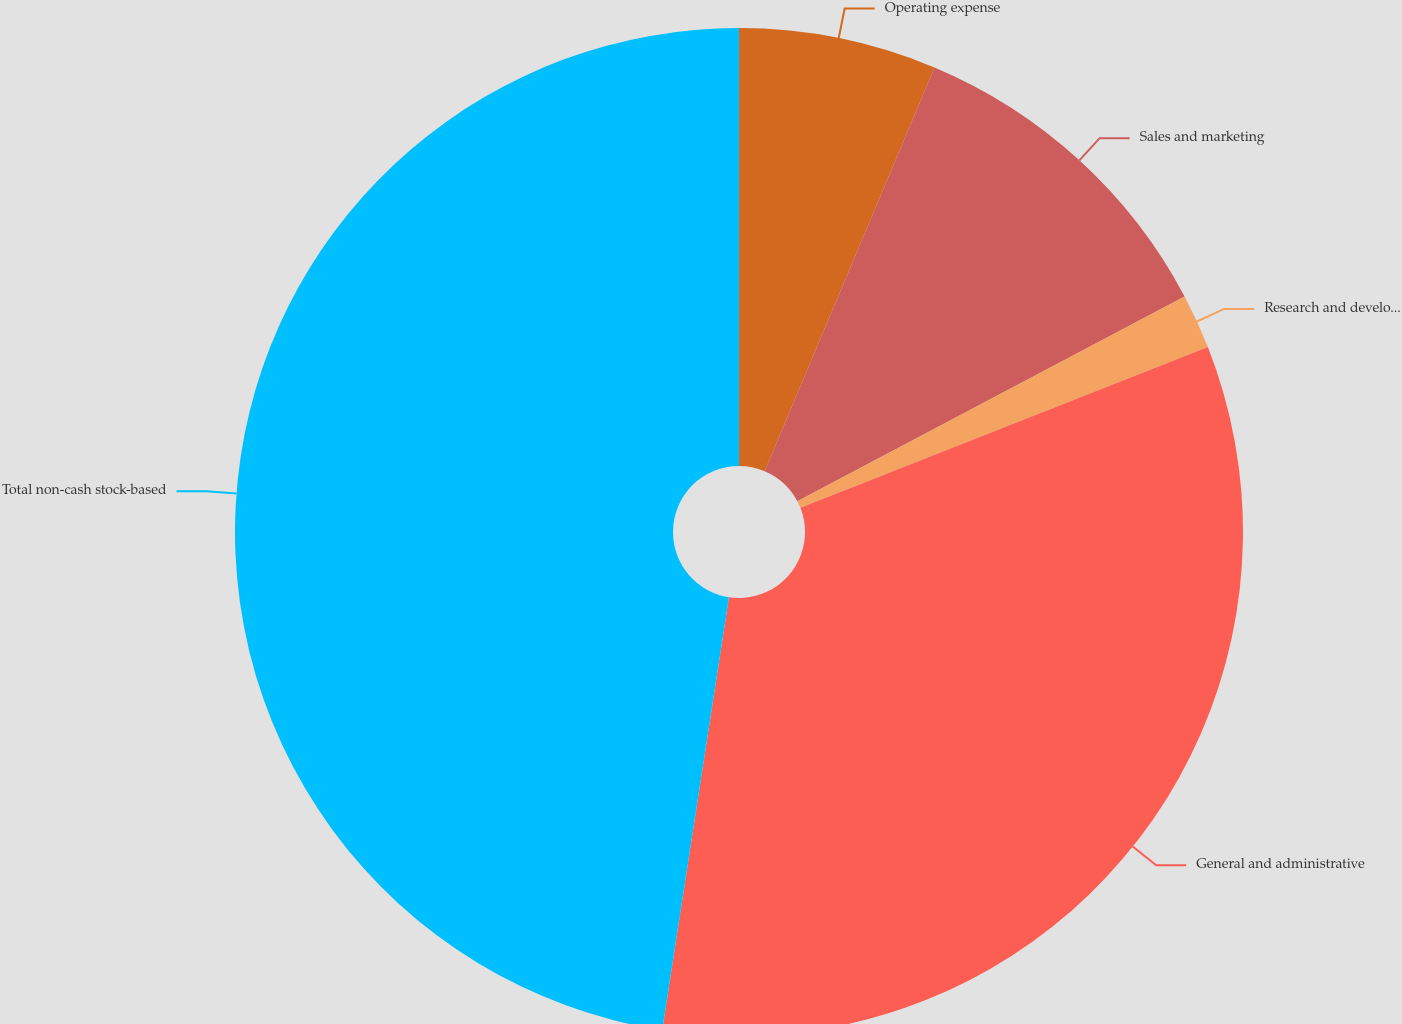<chart> <loc_0><loc_0><loc_500><loc_500><pie_chart><fcel>Operating expense<fcel>Sales and marketing<fcel>Research and development<fcel>General and administrative<fcel>Total non-cash stock-based<nl><fcel>6.34%<fcel>10.92%<fcel>1.76%<fcel>33.41%<fcel>47.56%<nl></chart> 